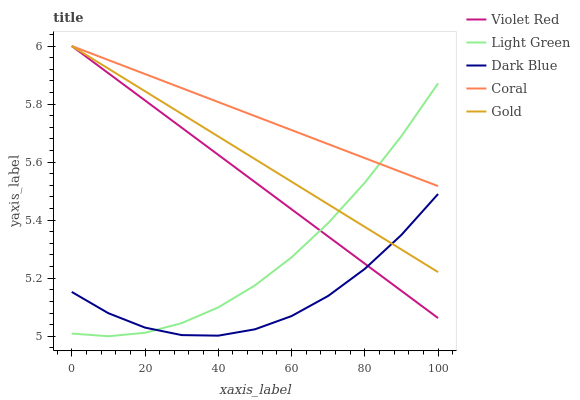Does Dark Blue have the minimum area under the curve?
Answer yes or no. Yes. Does Coral have the maximum area under the curve?
Answer yes or no. Yes. Does Violet Red have the minimum area under the curve?
Answer yes or no. No. Does Violet Red have the maximum area under the curve?
Answer yes or no. No. Is Violet Red the smoothest?
Answer yes or no. Yes. Is Dark Blue the roughest?
Answer yes or no. Yes. Is Gold the smoothest?
Answer yes or no. No. Is Gold the roughest?
Answer yes or no. No. Does Violet Red have the lowest value?
Answer yes or no. No. Does Light Green have the highest value?
Answer yes or no. No. Is Dark Blue less than Coral?
Answer yes or no. Yes. Is Coral greater than Dark Blue?
Answer yes or no. Yes. Does Dark Blue intersect Coral?
Answer yes or no. No. 